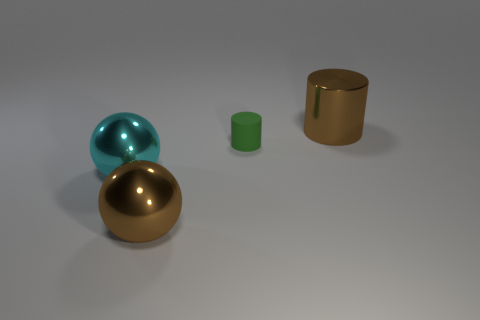The object behind the green cylinder is what color?
Your response must be concise. Brown. What is the color of the other big thing that is the same shape as the cyan shiny object?
Keep it short and to the point. Brown. Is there anything else that is the same color as the metal cylinder?
Provide a short and direct response. Yes. Is the number of cylinders greater than the number of things?
Your answer should be very brief. No. Is the material of the large brown ball the same as the brown cylinder?
Give a very brief answer. Yes. How many brown things have the same material as the cyan thing?
Provide a short and direct response. 2. Does the matte cylinder have the same size as the thing in front of the cyan metal ball?
Give a very brief answer. No. What is the color of the thing that is behind the large cyan shiny sphere and in front of the large brown metal cylinder?
Give a very brief answer. Green. There is a large brown metal object that is in front of the tiny rubber cylinder; are there any large brown objects that are behind it?
Offer a very short reply. Yes. Are there the same number of large brown metallic balls that are to the right of the big brown ball and small green shiny spheres?
Your answer should be very brief. Yes. 